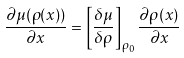Convert formula to latex. <formula><loc_0><loc_0><loc_500><loc_500>\frac { \partial \mu ( \rho ( x ) ) } { \partial x } = \left [ \frac { \delta \mu } { \delta \rho } \right ] _ { \rho _ { 0 } } \frac { \partial \rho ( x ) } { \partial x }</formula> 